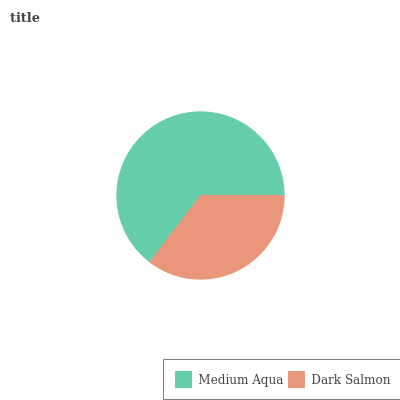Is Dark Salmon the minimum?
Answer yes or no. Yes. Is Medium Aqua the maximum?
Answer yes or no. Yes. Is Dark Salmon the maximum?
Answer yes or no. No. Is Medium Aqua greater than Dark Salmon?
Answer yes or no. Yes. Is Dark Salmon less than Medium Aqua?
Answer yes or no. Yes. Is Dark Salmon greater than Medium Aqua?
Answer yes or no. No. Is Medium Aqua less than Dark Salmon?
Answer yes or no. No. Is Medium Aqua the high median?
Answer yes or no. Yes. Is Dark Salmon the low median?
Answer yes or no. Yes. Is Dark Salmon the high median?
Answer yes or no. No. Is Medium Aqua the low median?
Answer yes or no. No. 